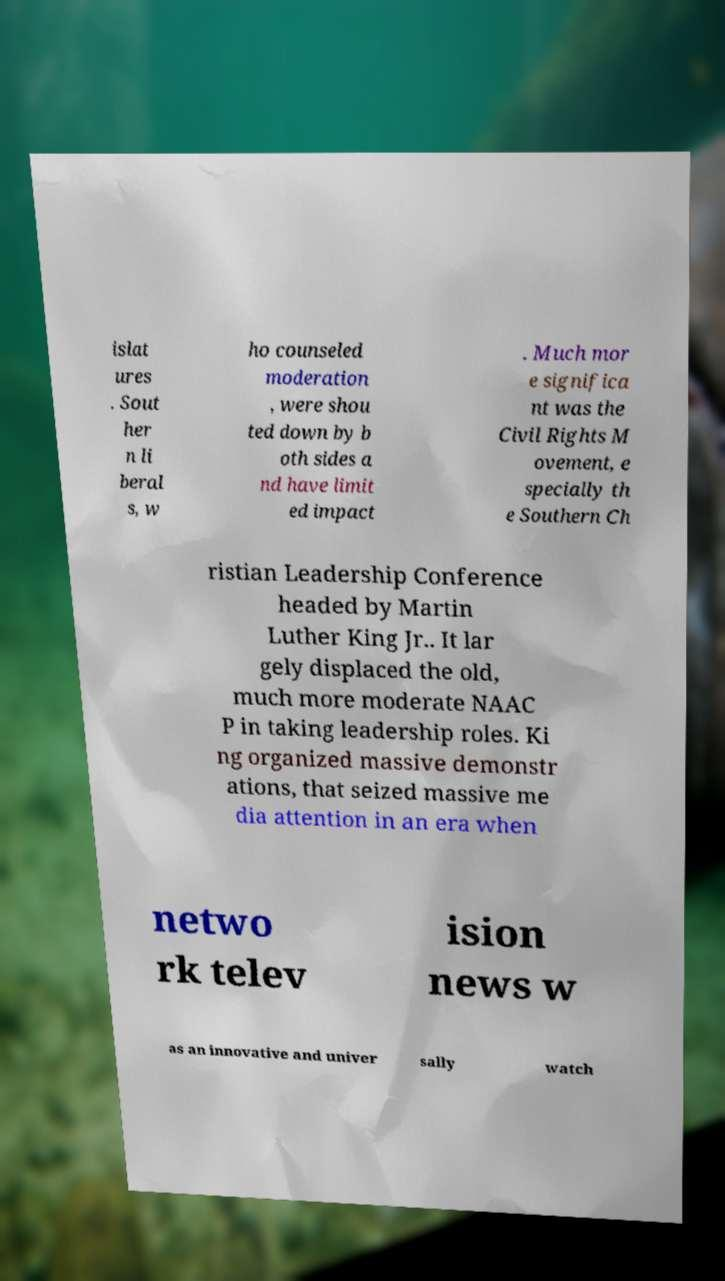Can you read and provide the text displayed in the image?This photo seems to have some interesting text. Can you extract and type it out for me? islat ures . Sout her n li beral s, w ho counseled moderation , were shou ted down by b oth sides a nd have limit ed impact . Much mor e significa nt was the Civil Rights M ovement, e specially th e Southern Ch ristian Leadership Conference headed by Martin Luther King Jr.. It lar gely displaced the old, much more moderate NAAC P in taking leadership roles. Ki ng organized massive demonstr ations, that seized massive me dia attention in an era when netwo rk telev ision news w as an innovative and univer sally watch 